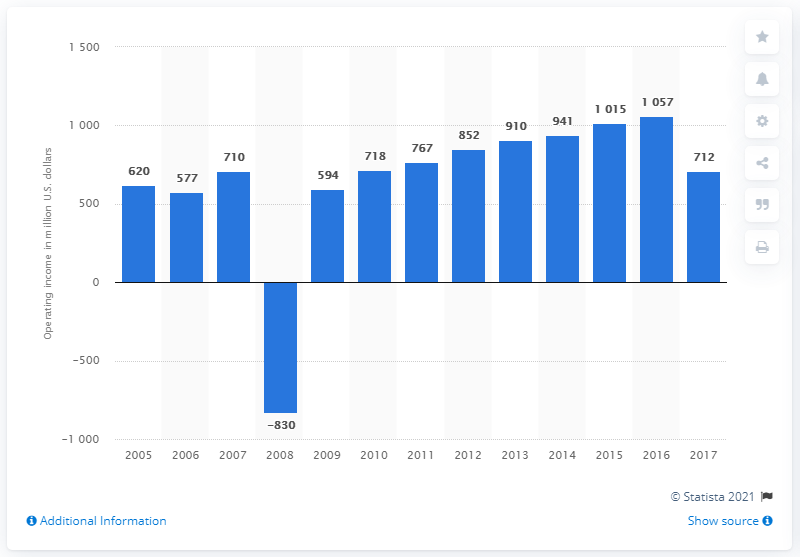Point out several critical features in this image. In 2017, the operating income of the Wyndham Worldwide Corporation was $712 million. 